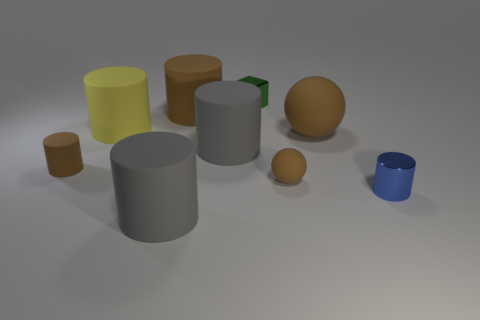Subtract all brown cylinders. How many cylinders are left? 4 Subtract all small cylinders. How many cylinders are left? 4 Subtract all green cylinders. Subtract all blue blocks. How many cylinders are left? 6 Subtract all cubes. How many objects are left? 8 Subtract all small cyan metallic cubes. Subtract all yellow rubber cylinders. How many objects are left? 8 Add 4 shiny objects. How many shiny objects are left? 6 Add 4 small brown balls. How many small brown balls exist? 5 Subtract 1 green blocks. How many objects are left? 8 